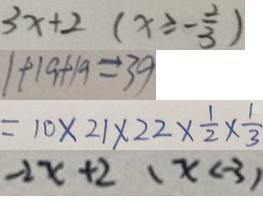<formula> <loc_0><loc_0><loc_500><loc_500>3 x + 2 ( x \geqslant - \frac { 2 } { 3 } ) 
 1 + 1 9 + 1 9 = 3 9 
 = 1 0 \times 2 1 \times 2 2 \times \frac { 1 } { 2 } \times \frac { 1 } { 3 } 
 - 2 x + 2 ( x < - 3 )</formula> 